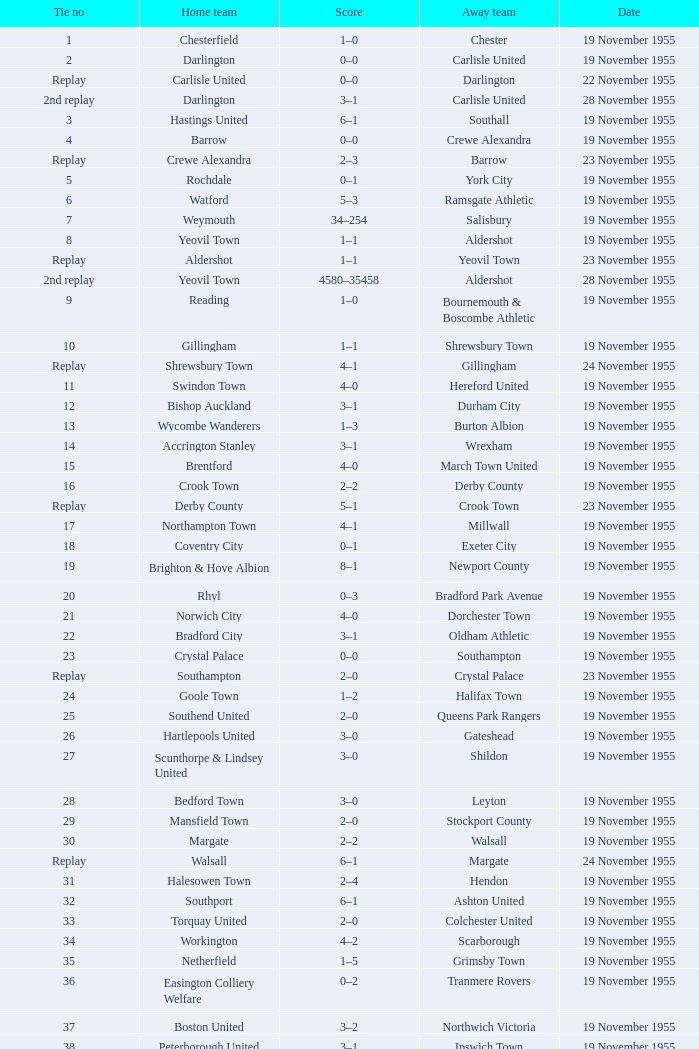What is the date of tie no. 34? 19 November 1955. 